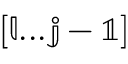Convert formula to latex. <formula><loc_0><loc_0><loc_500><loc_500>\mathbb { [ l \dots j - 1 ] }</formula> 